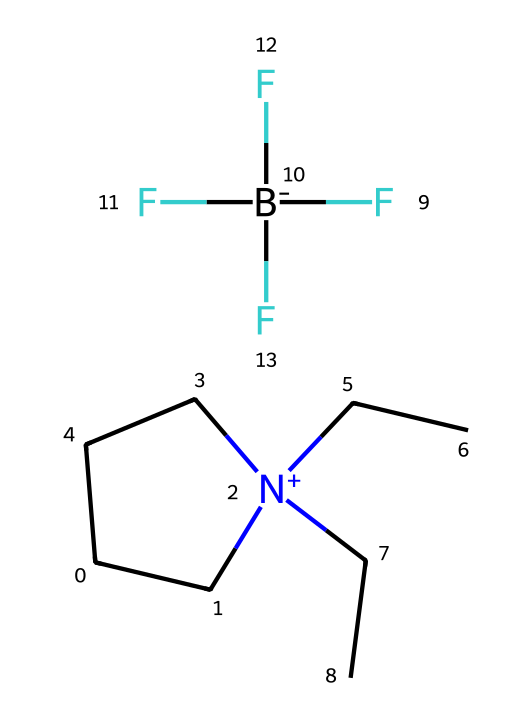What is the main cation in this ionic liquid? The main cation is identified by the presence of the nitrogen atom bonded to three carbon chains in the structure. In this case, the cation is derived from a cyclic structure with a nitrogen atom that has a positive charge.
Answer: C1C[N+](CC1)(CC)CC What type of anion is present in this ionic liquid? The anion is recognized by the presence of the fluorine atoms and the overall negative charge. In this case, the anion is a tetrafluoroborate, which consists of boron surrounded by four fluorine atoms.
Answer: F[B-](F)(F)F How many fluorine atoms are there in the anion? Counting the number of fluorine symbols (F) present in the anion part of the structure reveals there are four fluorine atoms bonded to the boron atom.
Answer: 4 What is the significance of the positive charge in this ionic liquid? The positive charge on the nitrogen makes it a quaternary ammonium ion, which is a characteristic feature of ionic liquids that contributes to their low volatility and high ionic conductivity, suitable for advanced battery applications.
Answer: Low volatility What property does this ionic liquid likely have due to its ionic nature? Being an ionic liquid, it exhibits properties such as low melting point and significant ionic conductivity, which are beneficial for use in battery electrolytes.
Answer: Ionic conductivity What structural feature makes this compound an ionic liquid? The presence of both a positively charged cation and a negatively charged anion in the structure allows it to be categorized as an ionic liquid, highlighting its ionic character.
Answer: Cation and anion 